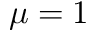<formula> <loc_0><loc_0><loc_500><loc_500>\mu = 1</formula> 